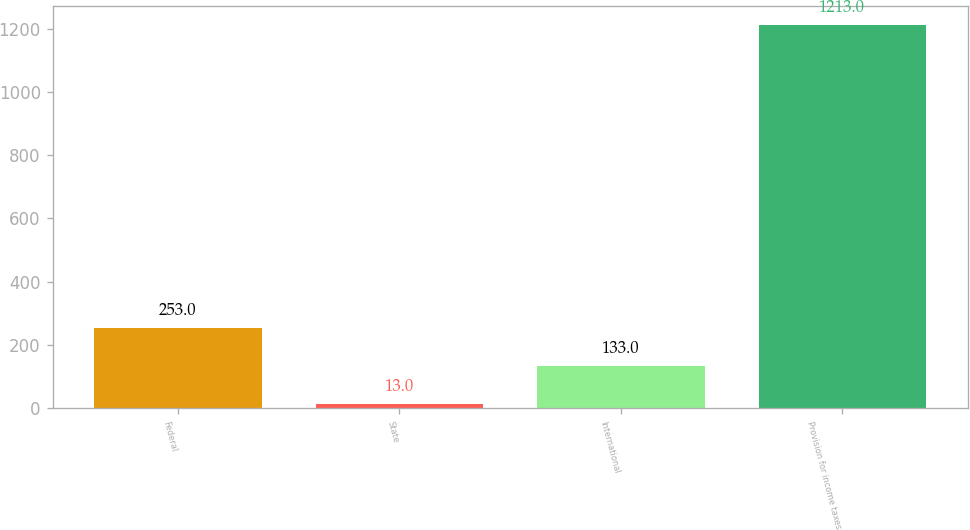Convert chart to OTSL. <chart><loc_0><loc_0><loc_500><loc_500><bar_chart><fcel>Federal<fcel>State<fcel>International<fcel>Provision for income taxes<nl><fcel>253<fcel>13<fcel>133<fcel>1213<nl></chart> 